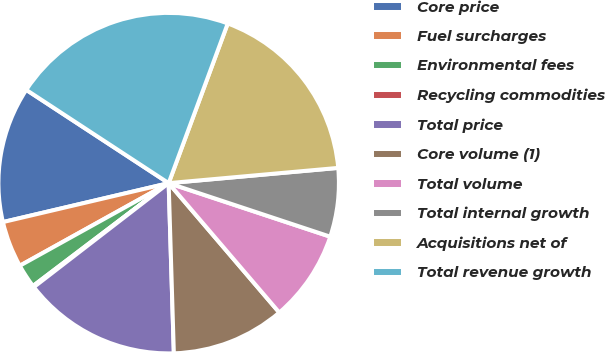<chart> <loc_0><loc_0><loc_500><loc_500><pie_chart><fcel>Core price<fcel>Fuel surcharges<fcel>Environmental fees<fcel>Recycling commodities<fcel>Total price<fcel>Core volume (1)<fcel>Total volume<fcel>Total internal growth<fcel>Acquisitions net of<fcel>Total revenue growth<nl><fcel>12.9%<fcel>4.39%<fcel>2.26%<fcel>0.13%<fcel>15.03%<fcel>10.77%<fcel>8.65%<fcel>6.52%<fcel>17.93%<fcel>21.41%<nl></chart> 